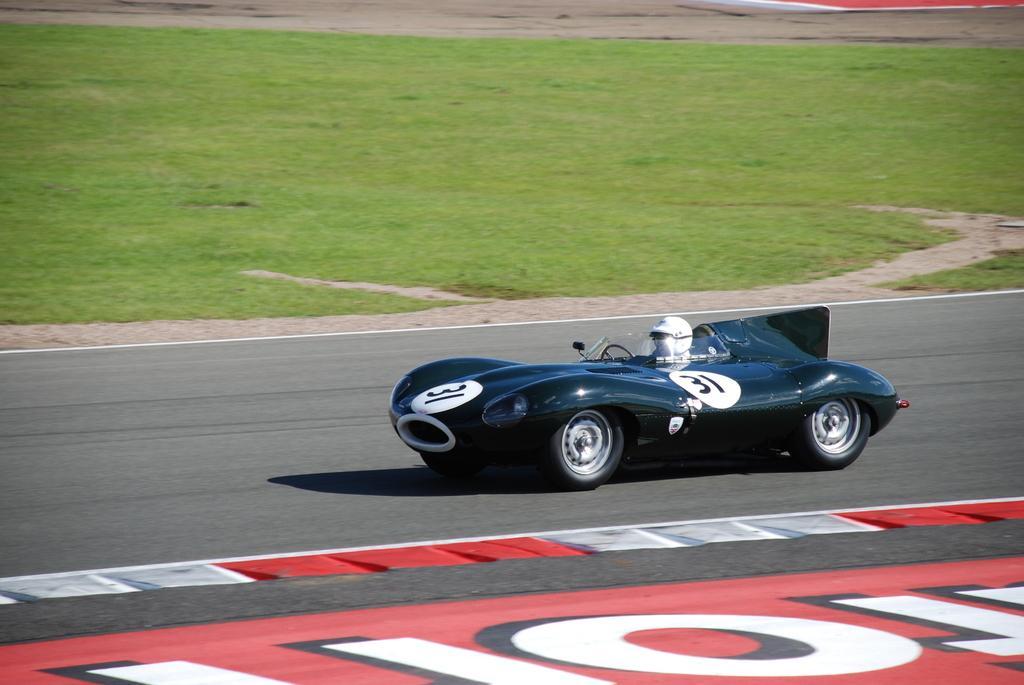Could you give a brief overview of what you see in this image? In this picture we can see a vehicle on the road. And a person is sitting on the vehicle and he wear a helmet. And this is the grass. 